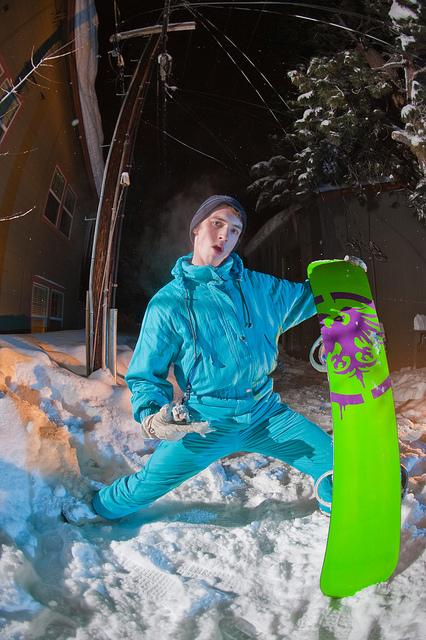What color are is his snowsuit?
Quick response, please. Blue. Where is the man holding a snowboard?
Concise answer only. In snow. Is the man dancing with the snowboard?
Keep it brief. No. 